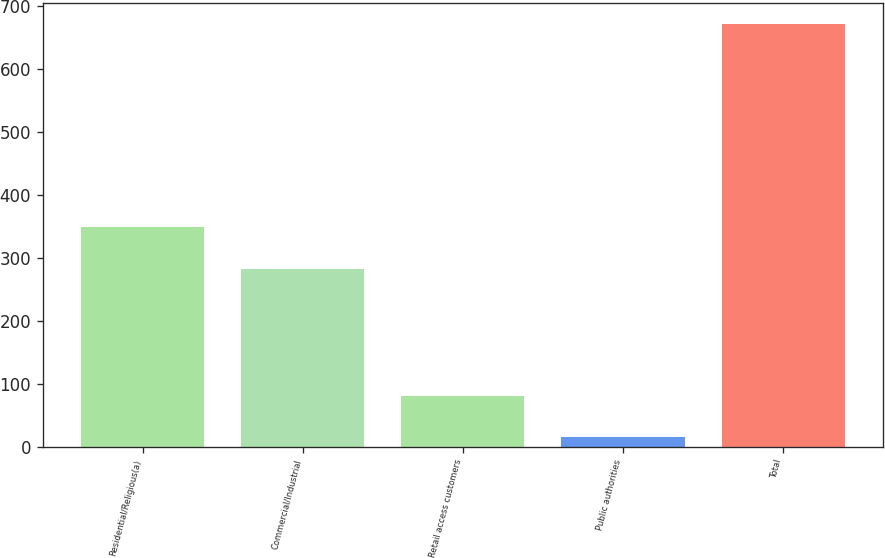Convert chart to OTSL. <chart><loc_0><loc_0><loc_500><loc_500><bar_chart><fcel>Residential/Religious(a)<fcel>Commercial/Industrial<fcel>Retail access customers<fcel>Public authorities<fcel>Total<nl><fcel>348.6<fcel>283<fcel>80.6<fcel>15<fcel>671<nl></chart> 